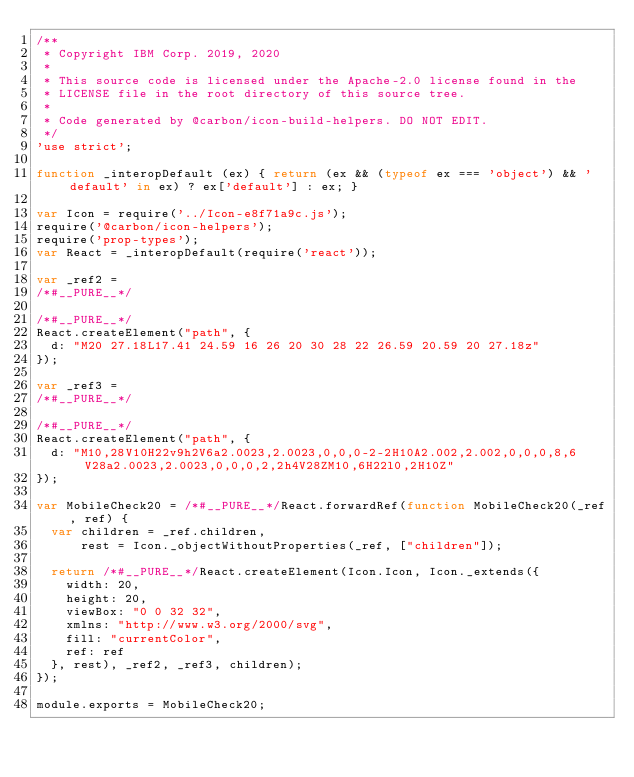<code> <loc_0><loc_0><loc_500><loc_500><_JavaScript_>/**
 * Copyright IBM Corp. 2019, 2020
 *
 * This source code is licensed under the Apache-2.0 license found in the
 * LICENSE file in the root directory of this source tree.
 *
 * Code generated by @carbon/icon-build-helpers. DO NOT EDIT.
 */
'use strict';

function _interopDefault (ex) { return (ex && (typeof ex === 'object') && 'default' in ex) ? ex['default'] : ex; }

var Icon = require('../Icon-e8f71a9c.js');
require('@carbon/icon-helpers');
require('prop-types');
var React = _interopDefault(require('react'));

var _ref2 =
/*#__PURE__*/

/*#__PURE__*/
React.createElement("path", {
  d: "M20 27.18L17.41 24.59 16 26 20 30 28 22 26.59 20.59 20 27.18z"
});

var _ref3 =
/*#__PURE__*/

/*#__PURE__*/
React.createElement("path", {
  d: "M10,28V10H22v9h2V6a2.0023,2.0023,0,0,0-2-2H10A2.002,2.002,0,0,0,8,6V28a2.0023,2.0023,0,0,0,2,2h4V28ZM10,6H22l0,2H10Z"
});

var MobileCheck20 = /*#__PURE__*/React.forwardRef(function MobileCheck20(_ref, ref) {
  var children = _ref.children,
      rest = Icon._objectWithoutProperties(_ref, ["children"]);

  return /*#__PURE__*/React.createElement(Icon.Icon, Icon._extends({
    width: 20,
    height: 20,
    viewBox: "0 0 32 32",
    xmlns: "http://www.w3.org/2000/svg",
    fill: "currentColor",
    ref: ref
  }, rest), _ref2, _ref3, children);
});

module.exports = MobileCheck20;
</code> 